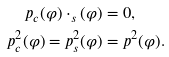Convert formula to latex. <formula><loc_0><loc_0><loc_500><loc_500>p _ { c } ( \varphi ) \cdot _ { s } ( \varphi ) & = 0 , \\ p _ { c } ^ { 2 } ( \varphi ) = p _ { s } ^ { 2 } ( \varphi ) & = p ^ { 2 } ( \varphi ) .</formula> 